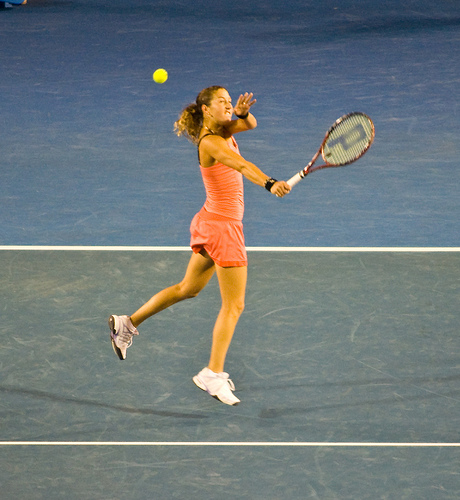Please transcribe the text in this image. P 